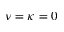Convert formula to latex. <formula><loc_0><loc_0><loc_500><loc_500>\nu = \kappa = 0</formula> 